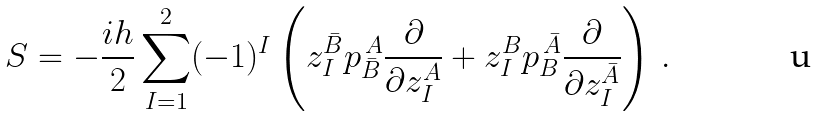<formula> <loc_0><loc_0><loc_500><loc_500>S = - \frac { i h } { 2 } \sum _ { I = 1 } ^ { 2 } ( - 1 ) ^ { I } \left ( { z } _ { I } ^ { \bar { B } } p _ { \bar { B } } ^ { \, A } \frac { \partial } { \partial z _ { I } ^ { A } } + { z } _ { I } ^ { B } p _ { B } ^ { \, \bar { A } } \frac { \partial } { \partial z _ { I } ^ { \bar { A } } } \right ) \, .</formula> 